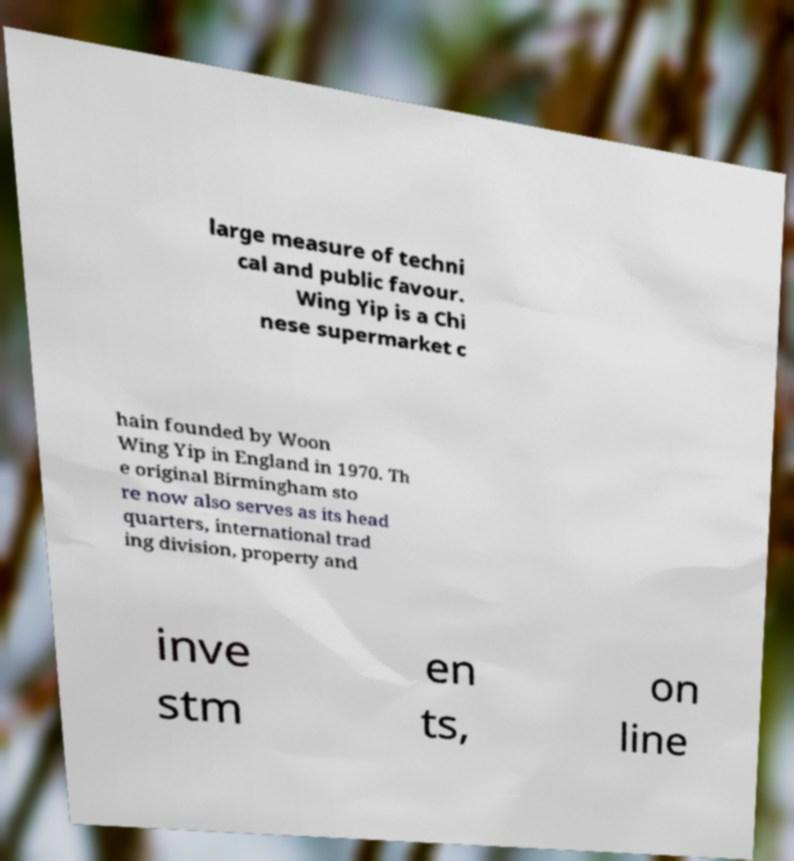Can you read and provide the text displayed in the image?This photo seems to have some interesting text. Can you extract and type it out for me? large measure of techni cal and public favour. Wing Yip is a Chi nese supermarket c hain founded by Woon Wing Yip in England in 1970. Th e original Birmingham sto re now also serves as its head quarters, international trad ing division, property and inve stm en ts, on line 